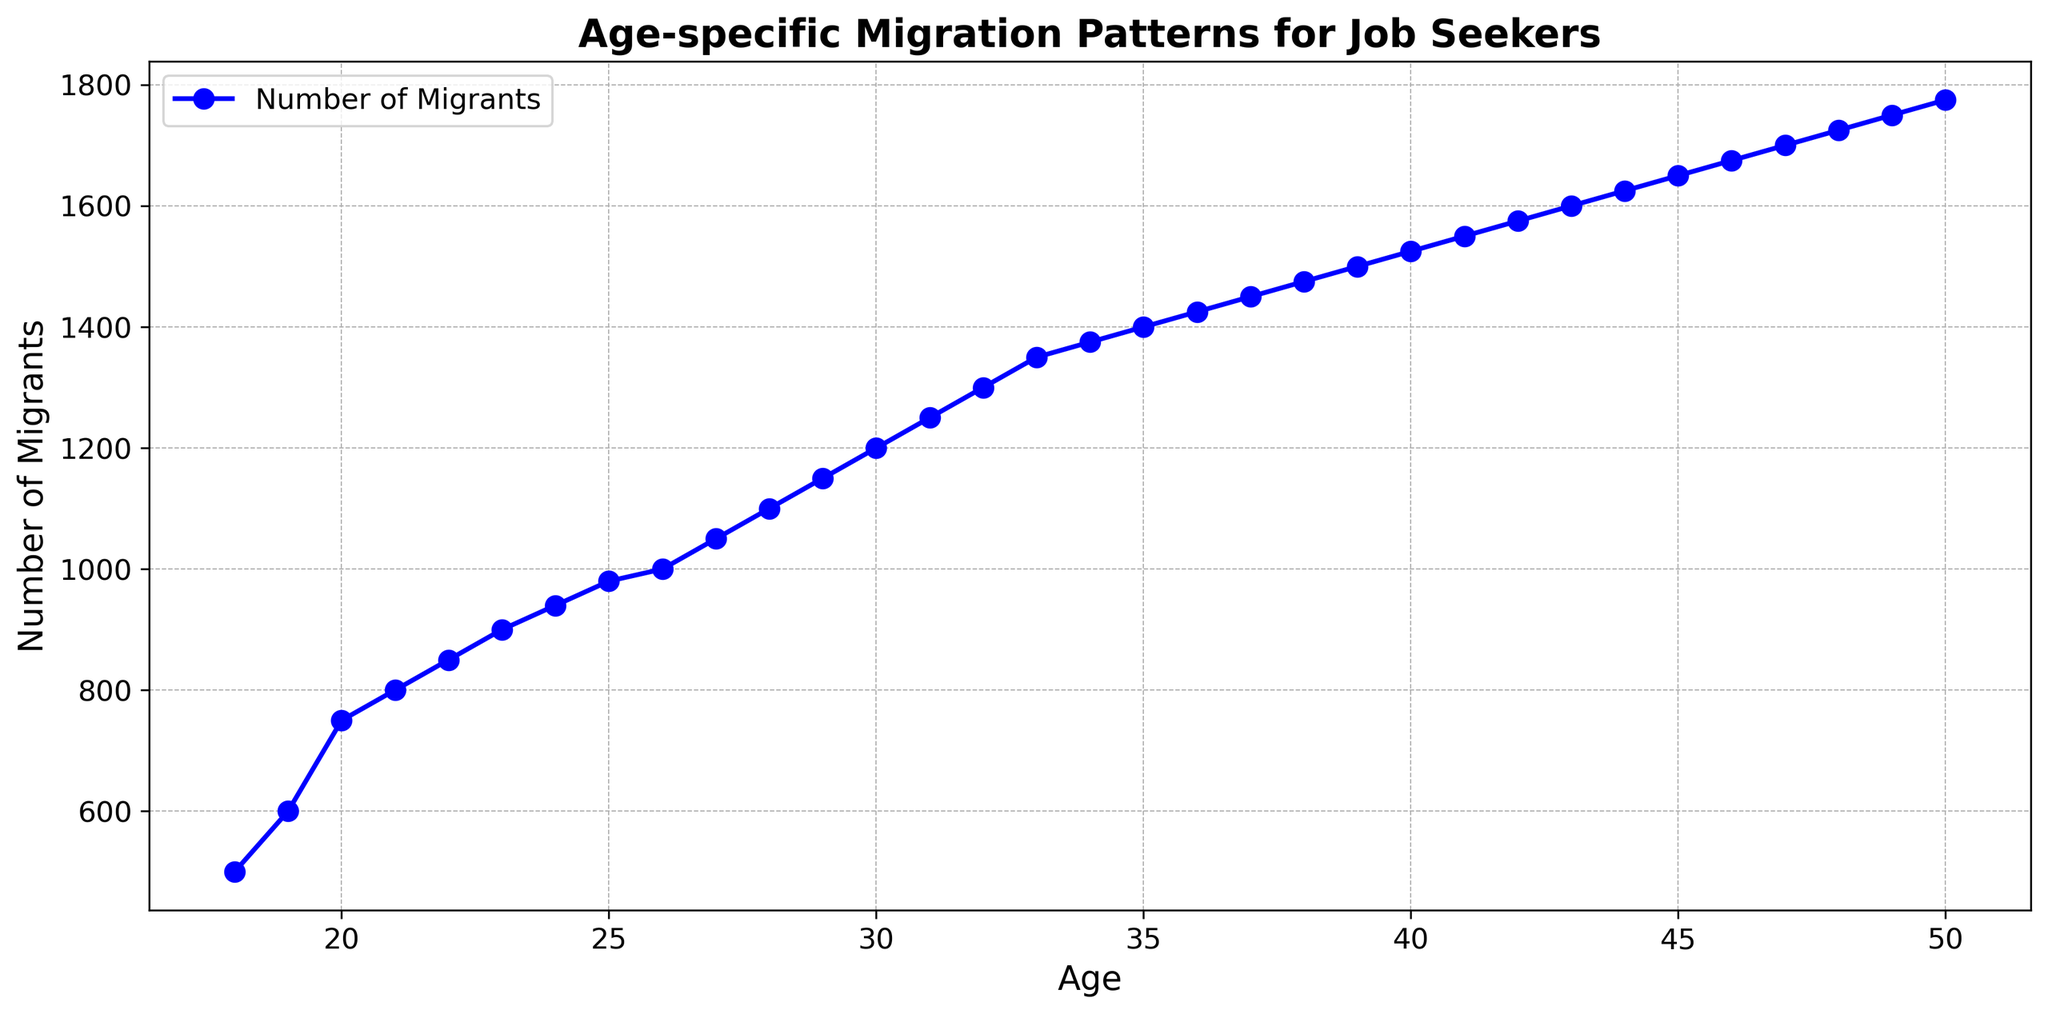What is the total number of migrants recorded between age 20 and age 25? To find the total number of migrants between ages 20 and 25, sum the corresponding values from the chart: 750 (age 20) + 800 (age 21) + 850 (age 22) + 900 (age 23) + 940 (age 24) + 980 (age 25) = 5220.
Answer: 5220 Which age group has the highest number of migrants, and what is that number? Look at the chart to find the highest point. The highest number of migrants is at age 50 with 1775 migrants.
Answer: 50, 1775 How does the number of migrants at age 30 compare to the number at age 40? The number of migrants at age 30 is 1200, and at age 40, it is 1525. Therefore, there are 325 more migrants at age 40 than at age 30.
Answer: 325 more migrants at age 40 What is the average number of migrants for ages 18 to 22? To calculate the average, add the number of migrants from ages 18 to 22 and divide by the number of ages. (500 + 600 + 750 + 800 + 850) / 5 = 700.
Answer: 700 Is there any age where the number of migrants is exactly 1000? Check the chart to see if there is an age where the number of migrants is 1000. At age 26, the number of migrants is 1000.
Answer: Yes, at age 26 How many more migrants are there at age 35 than at age 18? Subtract the number of migrants at age 18 from the number of migrants at age 35: 1400 (age 35) - 500 (age 18) = 900.
Answer: 900 more migrants At which age(s) do the number of migrants first exceed 1500? Examine the chart to find the first age where the migrant value crosses 1500. The number of migrants first exceeds 1500 at age 39.
Answer: Age 39 What is the range of the number of migrants between ages 30 and 40? Find the minimum and maximum values of migrants between ages 30 and 40. The minimum is 1200 (age 30), and the maximum is 1525 (age 40). The range is 1525 - 1200 = 325.
Answer: 325 Is the trend of migration increasing or decreasing with age? Observe the line plot. Generally, the trend shows an increase in the number of migrants as age increases.
Answer: Increasing 